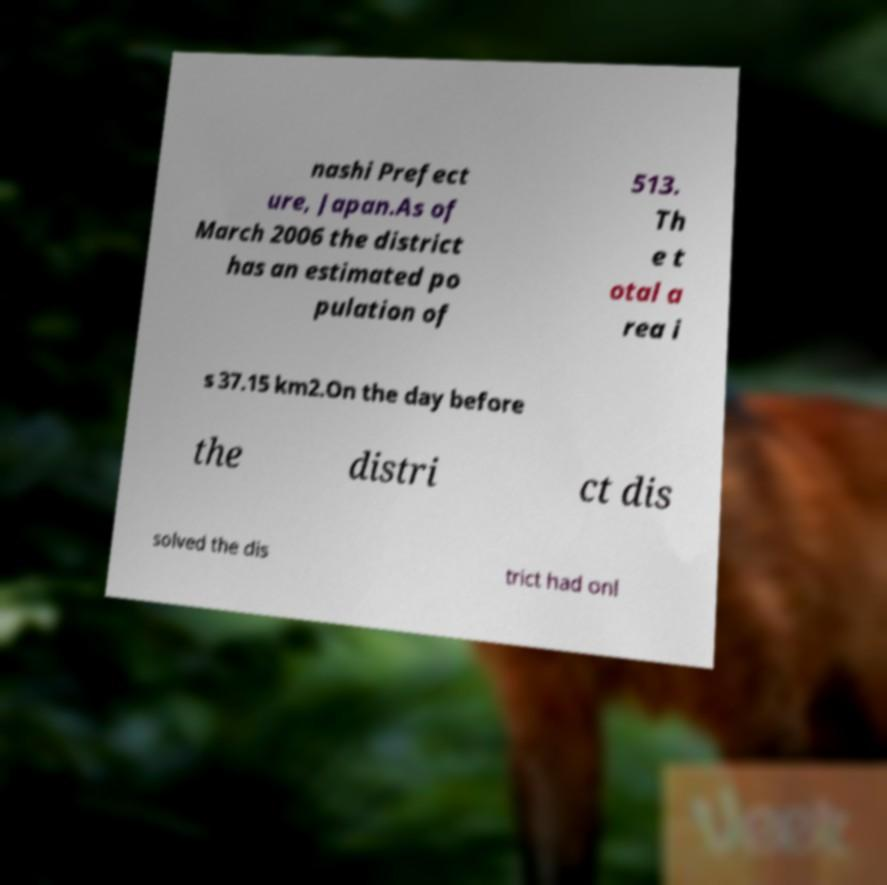Could you extract and type out the text from this image? nashi Prefect ure, Japan.As of March 2006 the district has an estimated po pulation of 513. Th e t otal a rea i s 37.15 km2.On the day before the distri ct dis solved the dis trict had onl 